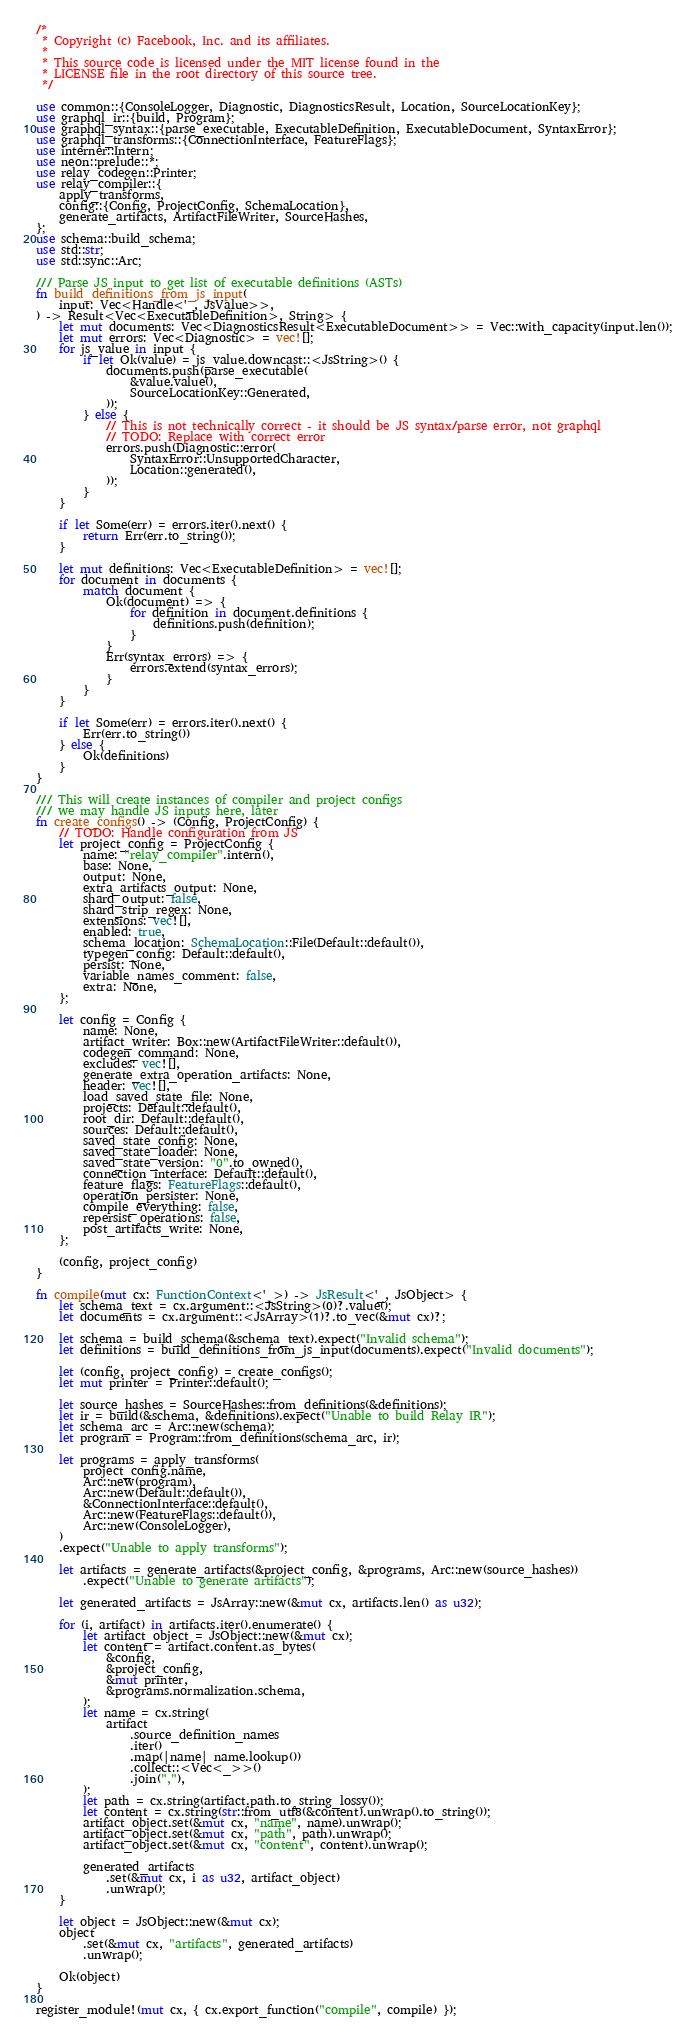<code> <loc_0><loc_0><loc_500><loc_500><_Rust_>/*
 * Copyright (c) Facebook, Inc. and its affiliates.
 *
 * This source code is licensed under the MIT license found in the
 * LICENSE file in the root directory of this source tree.
 */

use common::{ConsoleLogger, Diagnostic, DiagnosticsResult, Location, SourceLocationKey};
use graphql_ir::{build, Program};
use graphql_syntax::{parse_executable, ExecutableDefinition, ExecutableDocument, SyntaxError};
use graphql_transforms::{ConnectionInterface, FeatureFlags};
use interner::Intern;
use neon::prelude::*;
use relay_codegen::Printer;
use relay_compiler::{
    apply_transforms,
    config::{Config, ProjectConfig, SchemaLocation},
    generate_artifacts, ArtifactFileWriter, SourceHashes,
};
use schema::build_schema;
use std::str;
use std::sync::Arc;

/// Parse JS input to get list of executable definitions (ASTs)
fn build_definitions_from_js_input(
    input: Vec<Handle<'_, JsValue>>,
) -> Result<Vec<ExecutableDefinition>, String> {
    let mut documents: Vec<DiagnosticsResult<ExecutableDocument>> = Vec::with_capacity(input.len());
    let mut errors: Vec<Diagnostic> = vec![];
    for js_value in input {
        if let Ok(value) = js_value.downcast::<JsString>() {
            documents.push(parse_executable(
                &value.value(),
                SourceLocationKey::Generated,
            ));
        } else {
            // This is not technically correct - it should be JS syntax/parse error, not graphql
            // TODO: Replace with correct error
            errors.push(Diagnostic::error(
                SyntaxError::UnsupportedCharacter,
                Location::generated(),
            ));
        }
    }

    if let Some(err) = errors.iter().next() {
        return Err(err.to_string());
    }

    let mut definitions: Vec<ExecutableDefinition> = vec![];
    for document in documents {
        match document {
            Ok(document) => {
                for definition in document.definitions {
                    definitions.push(definition);
                }
            }
            Err(syntax_errors) => {
                errors.extend(syntax_errors);
            }
        }
    }

    if let Some(err) = errors.iter().next() {
        Err(err.to_string())
    } else {
        Ok(definitions)
    }
}

/// This will create instances of compiler and project configs
/// we may handle JS inputs here, later
fn create_configs() -> (Config, ProjectConfig) {
    // TODO: Handle configuration from JS
    let project_config = ProjectConfig {
        name: "relay_compiler".intern(),
        base: None,
        output: None,
        extra_artifacts_output: None,
        shard_output: false,
        shard_strip_regex: None,
        extensions: vec![],
        enabled: true,
        schema_location: SchemaLocation::File(Default::default()),
        typegen_config: Default::default(),
        persist: None,
        variable_names_comment: false,
        extra: None,
    };

    let config = Config {
        name: None,
        artifact_writer: Box::new(ArtifactFileWriter::default()),
        codegen_command: None,
        excludes: vec![],
        generate_extra_operation_artifacts: None,
        header: vec![],
        load_saved_state_file: None,
        projects: Default::default(),
        root_dir: Default::default(),
        sources: Default::default(),
        saved_state_config: None,
        saved_state_loader: None,
        saved_state_version: "0".to_owned(),
        connection_interface: Default::default(),
        feature_flags: FeatureFlags::default(),
        operation_persister: None,
        compile_everything: false,
        repersist_operations: false,
        post_artifacts_write: None,
    };

    (config, project_config)
}

fn compile(mut cx: FunctionContext<'_>) -> JsResult<'_, JsObject> {
    let schema_text = cx.argument::<JsString>(0)?.value();
    let documents = cx.argument::<JsArray>(1)?.to_vec(&mut cx)?;

    let schema = build_schema(&schema_text).expect("Invalid schema");
    let definitions = build_definitions_from_js_input(documents).expect("Invalid documents");

    let (config, project_config) = create_configs();
    let mut printer = Printer::default();

    let source_hashes = SourceHashes::from_definitions(&definitions);
    let ir = build(&schema, &definitions).expect("Unable to build Relay IR");
    let schema_arc = Arc::new(schema);
    let program = Program::from_definitions(schema_arc, ir);

    let programs = apply_transforms(
        project_config.name,
        Arc::new(program),
        Arc::new(Default::default()),
        &ConnectionInterface::default(),
        Arc::new(FeatureFlags::default()),
        Arc::new(ConsoleLogger),
    )
    .expect("Unable to apply transforms");

    let artifacts = generate_artifacts(&project_config, &programs, Arc::new(source_hashes))
        .expect("Unable to generate artifacts");

    let generated_artifacts = JsArray::new(&mut cx, artifacts.len() as u32);

    for (i, artifact) in artifacts.iter().enumerate() {
        let artifact_object = JsObject::new(&mut cx);
        let content = artifact.content.as_bytes(
            &config,
            &project_config,
            &mut printer,
            &programs.normalization.schema,
        );
        let name = cx.string(
            artifact
                .source_definition_names
                .iter()
                .map(|name| name.lookup())
                .collect::<Vec<_>>()
                .join(","),
        );
        let path = cx.string(artifact.path.to_string_lossy());
        let content = cx.string(str::from_utf8(&content).unwrap().to_string());
        artifact_object.set(&mut cx, "name", name).unwrap();
        artifact_object.set(&mut cx, "path", path).unwrap();
        artifact_object.set(&mut cx, "content", content).unwrap();

        generated_artifacts
            .set(&mut cx, i as u32, artifact_object)
            .unwrap();
    }

    let object = JsObject::new(&mut cx);
    object
        .set(&mut cx, "artifacts", generated_artifacts)
        .unwrap();

    Ok(object)
}

register_module!(mut cx, { cx.export_function("compile", compile) });
</code> 